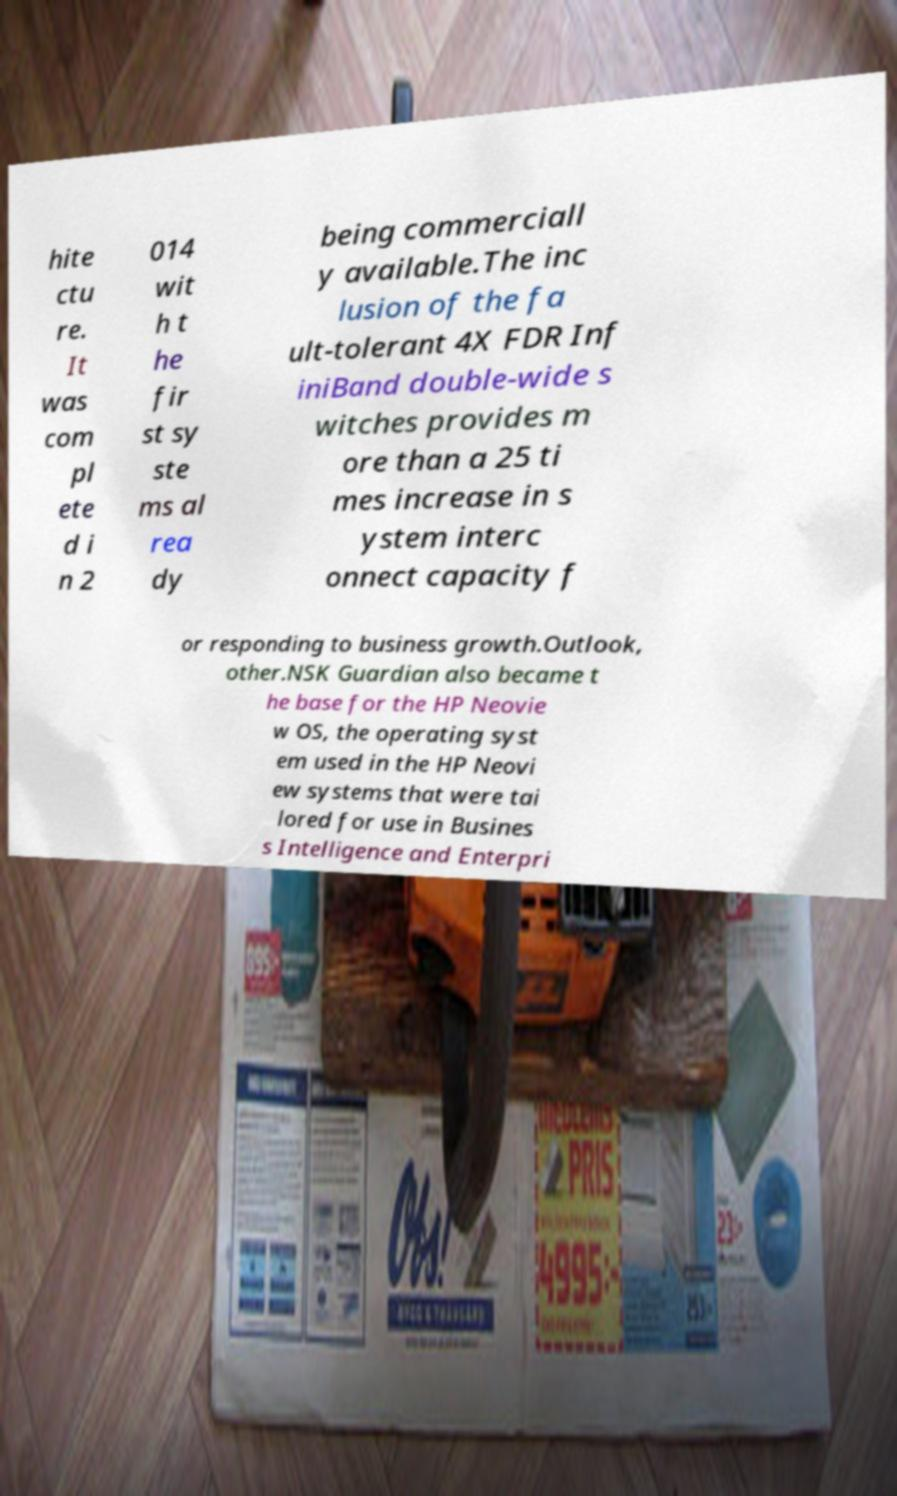I need the written content from this picture converted into text. Can you do that? hite ctu re. It was com pl ete d i n 2 014 wit h t he fir st sy ste ms al rea dy being commerciall y available.The inc lusion of the fa ult-tolerant 4X FDR Inf iniBand double-wide s witches provides m ore than a 25 ti mes increase in s ystem interc onnect capacity f or responding to business growth.Outlook, other.NSK Guardian also became t he base for the HP Neovie w OS, the operating syst em used in the HP Neovi ew systems that were tai lored for use in Busines s Intelligence and Enterpri 